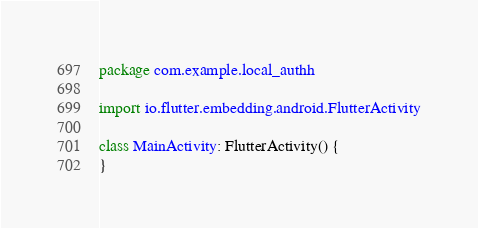<code> <loc_0><loc_0><loc_500><loc_500><_Kotlin_>package com.example.local_authh

import io.flutter.embedding.android.FlutterActivity

class MainActivity: FlutterActivity() {
}
</code> 